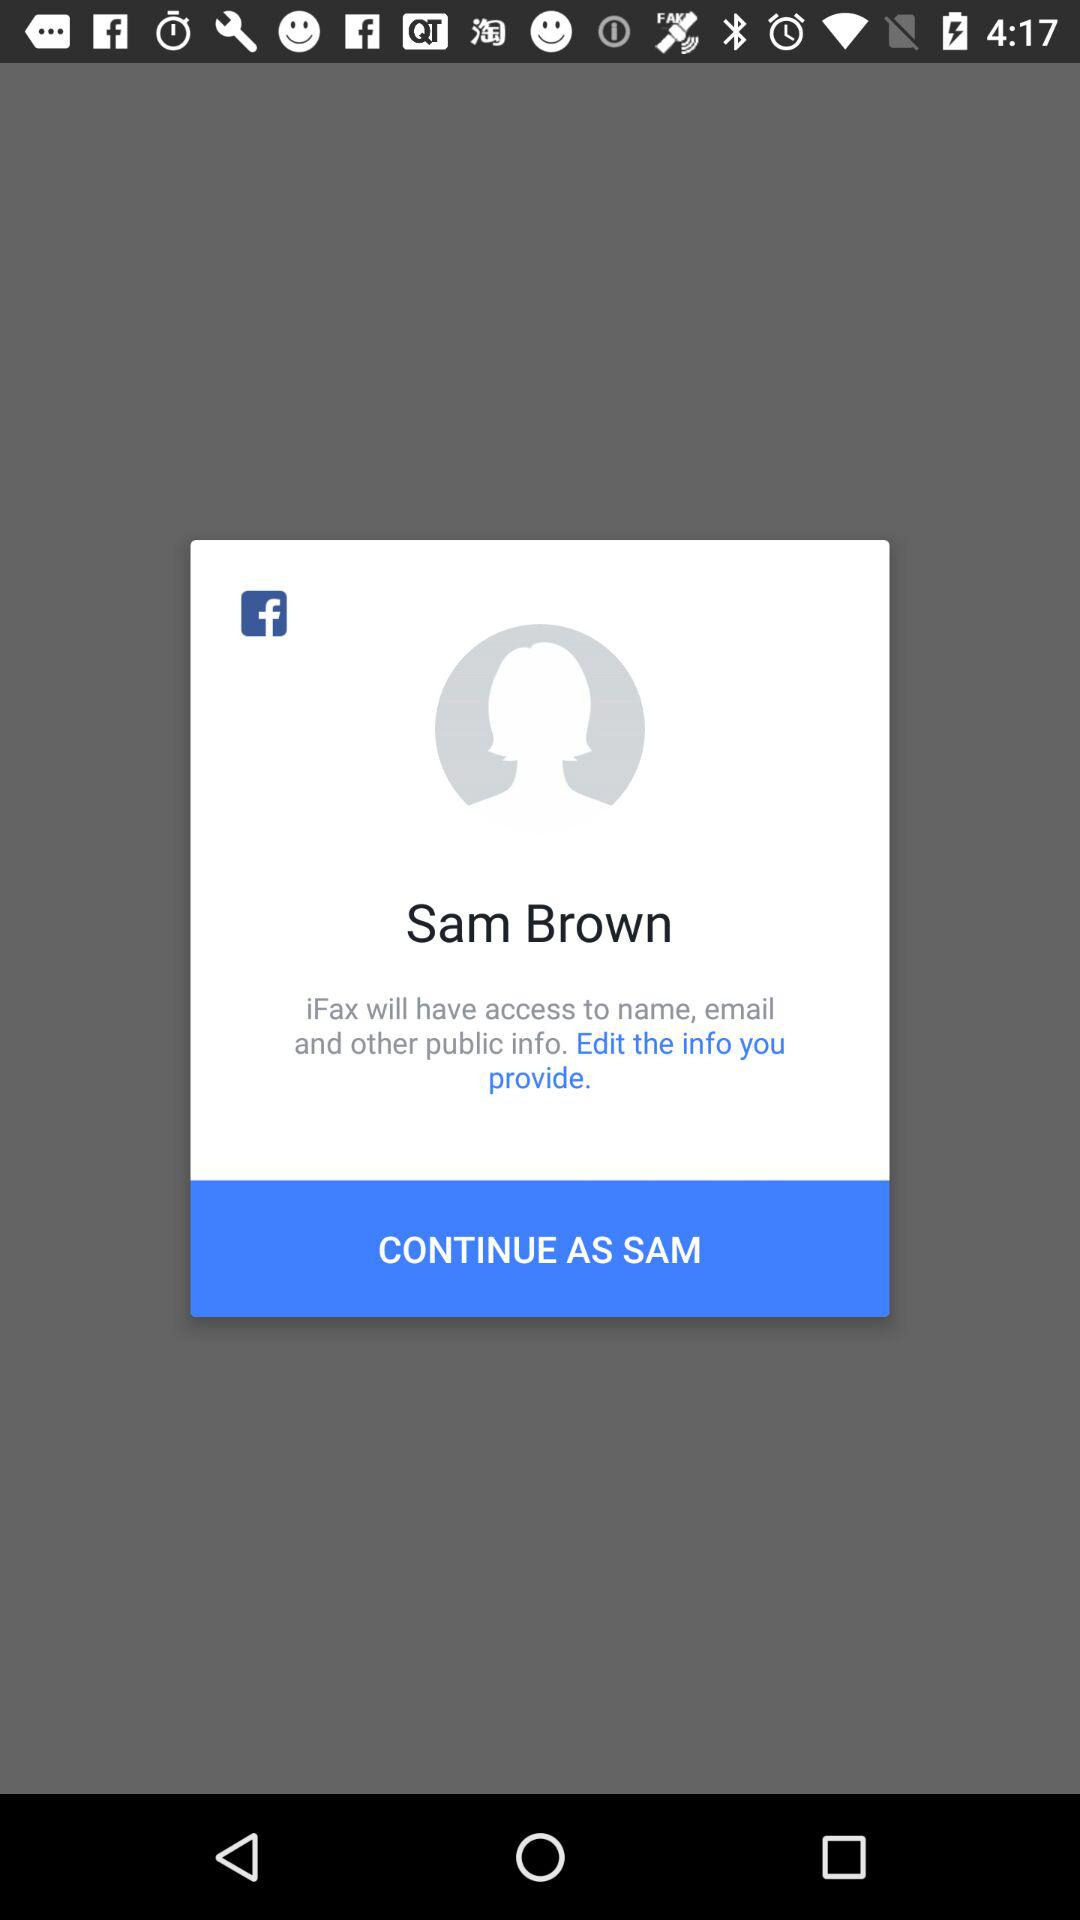What is the name of the user? The name of the user is Sam Brown. 